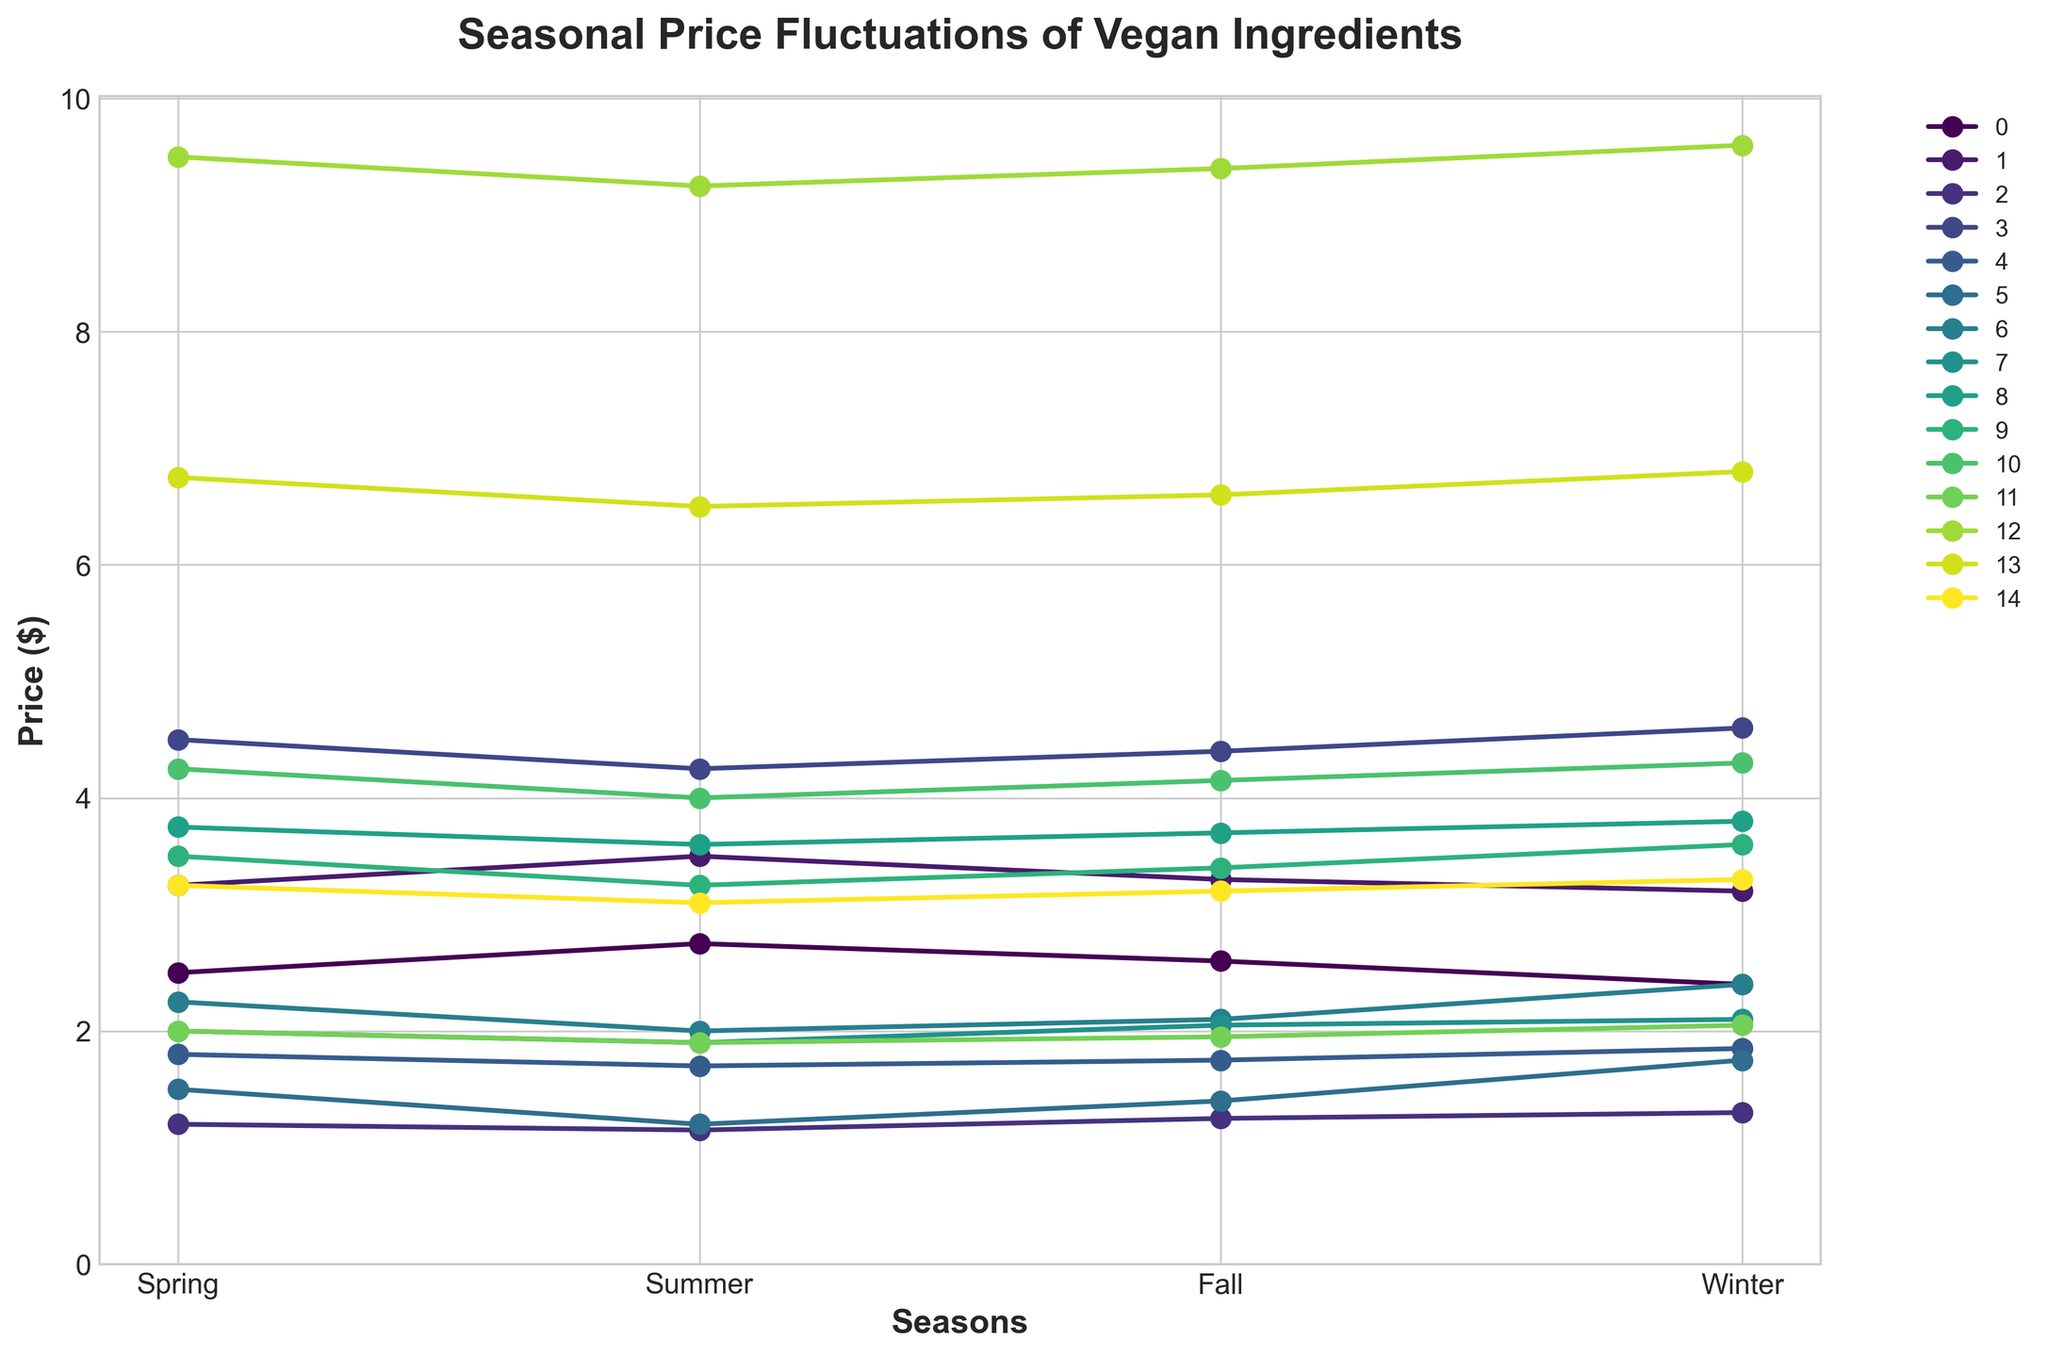Which ingredient has the highest price fluctuation over the seasons? To determine the highest price fluctuation, calculate the price range for each ingredient by subtracting the minimum price from the maximum price. The ingredient with the largest range is the one with the highest fluctuation. For Cashews, the range is 9.60 - 9.25 = 0.35, which is the highest among others.
Answer: Cashews Which season typically has the lowest prices for most ingredients? Look at each ingredient's price across the seasons and identify the season where prices are most frequently the lowest. Summer has the lowest prices for 10 out of the 15 ingredients, hence it typically has the lowest prices.
Answer: Summer Between Spring and Winter, which season has higher prices for Avocado? Compare the price of Avocado in Spring and Winter. In Spring, the price is $1.50, and in Winter, it is $1.75. Since $1.75 is greater than $1.50, Winter has higher prices for Avocado compared to Spring.
Answer: Winter What's the average price of Tofu over the four seasons? To find the average price of Tofu, sum up its prices over the four seasons (2.50 + 2.75 + 2.60 + 2.40) and divide by four. The summation is 10.25, hence the average price is 10.25 / 4 = 2.5625.
Answer: 2.5625 In which season does Beyond Meat Burger have the lowest price, and how much is it? To find the season with the lowest price for Beyond Meat Burger, compare its prices across all four seasons. The lowest price is $3.25, which occurs in Summer.
Answer: Summer, $3.25 Compare the price trends of Chickpeas and Kale. Are there any similarities? Examine the line patterns for both Chickpeas and Kale across the seasons. Both Chickpeas and Kale reach their lowest prices in Summer and their highest prices in Winter. This similarity indicates a parallel trend.
Answer: Yes, similar trends What is the price difference between Flax Seeds in Summer and Winter? To find the price difference, subtract the price of Flax Seeds in Summer from the price in Winter. The prices are $3.10 in Summer and $3.30 in Winter. Therefore, the difference is 3.30 - 3.10 = 0.20.
Answer: 0.20 What's the general trend in the price of Nutritional Yeast over the seasons? The trend is determined by observing the progression of prices across the seasons. The price of Nutritional Yeast starts at $1.20 in Spring, decreases to $1.15 in Summer, then increases to $1.25 in Fall, and further to $1.30 in Winter, showing an overall upward trend.
Answer: Upward trend Which ingredient has the smallest seasonal price range, and what is that range? Calculate the price range (max price - min price) for each ingredient. The smallest range is for Chickpeas, where the max is $1.85 and the min is $1.70, giving a range of $1.85 - $1.70 = 0.15.
Answer: Chickpeas, 0.15 What is the price pattern for Lentils across the seasons? Observe the changes in price for Lentils over the seasons. The price decreases from Spring ($2.00) to Summer ($1.90), then slightly increases through Fall ($1.95) and Winter ($2.05), making a V-shaped pattern.
Answer: V-shaped pattern 